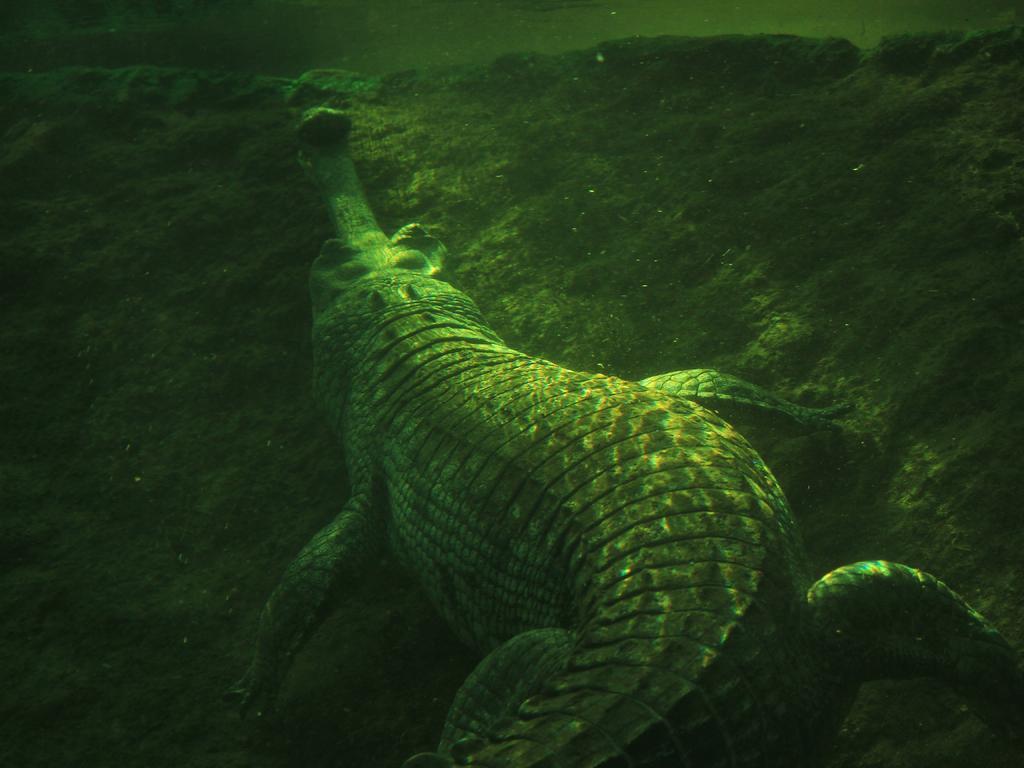Can you describe this image briefly? In the foreground of this image, there is a crocodile under the water on the rock like surface. 